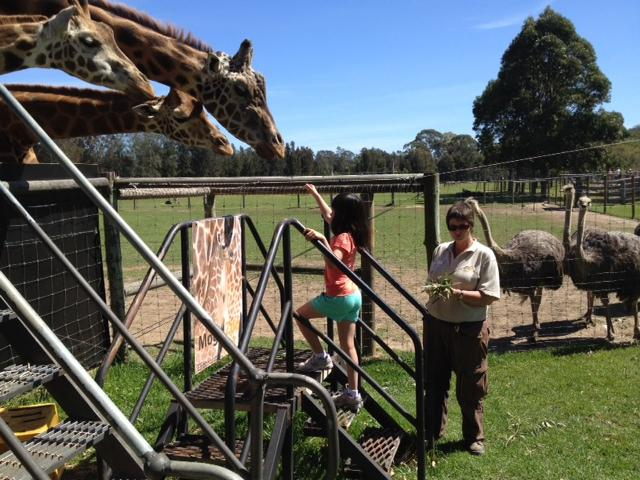Why is the short haired woman wearing a khaki shirt? uniform 